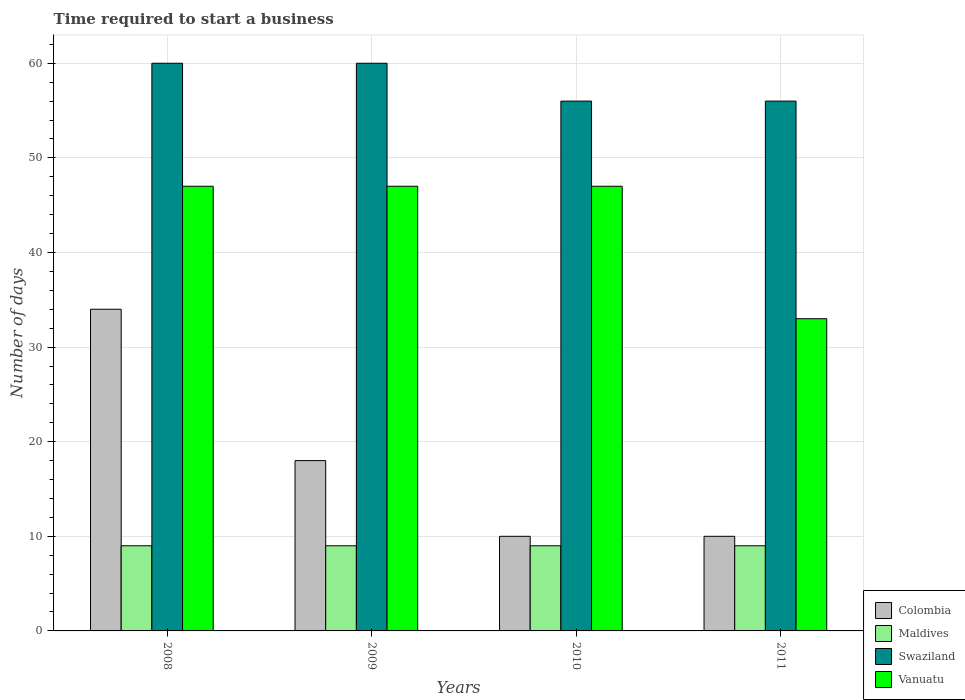How many different coloured bars are there?
Provide a short and direct response. 4. How many groups of bars are there?
Provide a succinct answer. 4. Are the number of bars per tick equal to the number of legend labels?
Provide a short and direct response. Yes. How many bars are there on the 1st tick from the left?
Provide a succinct answer. 4. How many bars are there on the 3rd tick from the right?
Provide a succinct answer. 4. What is the label of the 2nd group of bars from the left?
Your answer should be very brief. 2009. In how many cases, is the number of bars for a given year not equal to the number of legend labels?
Provide a short and direct response. 0. What is the number of days required to start a business in Maldives in 2008?
Make the answer very short. 9. Across all years, what is the maximum number of days required to start a business in Swaziland?
Ensure brevity in your answer.  60. Across all years, what is the minimum number of days required to start a business in Colombia?
Your answer should be compact. 10. In which year was the number of days required to start a business in Maldives maximum?
Your response must be concise. 2008. In which year was the number of days required to start a business in Maldives minimum?
Give a very brief answer. 2008. What is the total number of days required to start a business in Vanuatu in the graph?
Give a very brief answer. 174. What is the difference between the number of days required to start a business in Vanuatu in 2008 and that in 2010?
Keep it short and to the point. 0. What is the difference between the number of days required to start a business in Swaziland in 2011 and the number of days required to start a business in Maldives in 2010?
Provide a succinct answer. 47. In the year 2009, what is the difference between the number of days required to start a business in Maldives and number of days required to start a business in Swaziland?
Offer a very short reply. -51. Is the number of days required to start a business in Vanuatu in 2008 less than that in 2010?
Make the answer very short. No. What is the difference between the highest and the lowest number of days required to start a business in Maldives?
Provide a short and direct response. 0. What does the 2nd bar from the left in 2008 represents?
Your response must be concise. Maldives. What does the 2nd bar from the right in 2011 represents?
Your answer should be compact. Swaziland. Is it the case that in every year, the sum of the number of days required to start a business in Colombia and number of days required to start a business in Vanuatu is greater than the number of days required to start a business in Swaziland?
Your answer should be compact. No. Are all the bars in the graph horizontal?
Make the answer very short. No. Does the graph contain grids?
Make the answer very short. Yes. How many legend labels are there?
Your response must be concise. 4. What is the title of the graph?
Provide a succinct answer. Time required to start a business. What is the label or title of the X-axis?
Give a very brief answer. Years. What is the label or title of the Y-axis?
Your response must be concise. Number of days. What is the Number of days of Colombia in 2008?
Provide a short and direct response. 34. What is the Number of days of Swaziland in 2008?
Ensure brevity in your answer.  60. What is the Number of days in Maldives in 2009?
Provide a succinct answer. 9. What is the Number of days of Swaziland in 2009?
Provide a succinct answer. 60. What is the Number of days of Vanuatu in 2009?
Your response must be concise. 47. What is the Number of days of Colombia in 2010?
Ensure brevity in your answer.  10. What is the Number of days in Swaziland in 2010?
Keep it short and to the point. 56. What is the Number of days of Colombia in 2011?
Offer a very short reply. 10. What is the Number of days in Swaziland in 2011?
Provide a short and direct response. 56. Across all years, what is the maximum Number of days of Colombia?
Provide a short and direct response. 34. Across all years, what is the maximum Number of days in Maldives?
Your answer should be very brief. 9. Across all years, what is the minimum Number of days in Colombia?
Offer a very short reply. 10. Across all years, what is the minimum Number of days in Maldives?
Ensure brevity in your answer.  9. What is the total Number of days in Colombia in the graph?
Provide a succinct answer. 72. What is the total Number of days of Swaziland in the graph?
Keep it short and to the point. 232. What is the total Number of days in Vanuatu in the graph?
Ensure brevity in your answer.  174. What is the difference between the Number of days of Maldives in 2008 and that in 2009?
Provide a succinct answer. 0. What is the difference between the Number of days of Vanuatu in 2008 and that in 2009?
Ensure brevity in your answer.  0. What is the difference between the Number of days in Maldives in 2008 and that in 2010?
Offer a very short reply. 0. What is the difference between the Number of days in Vanuatu in 2008 and that in 2010?
Your answer should be compact. 0. What is the difference between the Number of days of Swaziland in 2008 and that in 2011?
Give a very brief answer. 4. What is the difference between the Number of days in Vanuatu in 2008 and that in 2011?
Your answer should be very brief. 14. What is the difference between the Number of days of Swaziland in 2009 and that in 2010?
Offer a very short reply. 4. What is the difference between the Number of days of Colombia in 2009 and that in 2011?
Your answer should be compact. 8. What is the difference between the Number of days of Swaziland in 2009 and that in 2011?
Your answer should be compact. 4. What is the difference between the Number of days of Swaziland in 2010 and that in 2011?
Give a very brief answer. 0. What is the difference between the Number of days in Vanuatu in 2010 and that in 2011?
Offer a very short reply. 14. What is the difference between the Number of days in Colombia in 2008 and the Number of days in Vanuatu in 2009?
Your answer should be very brief. -13. What is the difference between the Number of days of Maldives in 2008 and the Number of days of Swaziland in 2009?
Offer a terse response. -51. What is the difference between the Number of days in Maldives in 2008 and the Number of days in Vanuatu in 2009?
Offer a terse response. -38. What is the difference between the Number of days in Maldives in 2008 and the Number of days in Swaziland in 2010?
Provide a succinct answer. -47. What is the difference between the Number of days of Maldives in 2008 and the Number of days of Vanuatu in 2010?
Your response must be concise. -38. What is the difference between the Number of days in Colombia in 2008 and the Number of days in Maldives in 2011?
Your answer should be compact. 25. What is the difference between the Number of days in Colombia in 2008 and the Number of days in Vanuatu in 2011?
Offer a terse response. 1. What is the difference between the Number of days of Maldives in 2008 and the Number of days of Swaziland in 2011?
Provide a short and direct response. -47. What is the difference between the Number of days in Maldives in 2008 and the Number of days in Vanuatu in 2011?
Give a very brief answer. -24. What is the difference between the Number of days of Swaziland in 2008 and the Number of days of Vanuatu in 2011?
Your answer should be very brief. 27. What is the difference between the Number of days in Colombia in 2009 and the Number of days in Maldives in 2010?
Offer a very short reply. 9. What is the difference between the Number of days of Colombia in 2009 and the Number of days of Swaziland in 2010?
Provide a short and direct response. -38. What is the difference between the Number of days in Colombia in 2009 and the Number of days in Vanuatu in 2010?
Give a very brief answer. -29. What is the difference between the Number of days of Maldives in 2009 and the Number of days of Swaziland in 2010?
Ensure brevity in your answer.  -47. What is the difference between the Number of days in Maldives in 2009 and the Number of days in Vanuatu in 2010?
Provide a succinct answer. -38. What is the difference between the Number of days of Colombia in 2009 and the Number of days of Swaziland in 2011?
Keep it short and to the point. -38. What is the difference between the Number of days in Maldives in 2009 and the Number of days in Swaziland in 2011?
Keep it short and to the point. -47. What is the difference between the Number of days in Swaziland in 2009 and the Number of days in Vanuatu in 2011?
Your response must be concise. 27. What is the difference between the Number of days of Colombia in 2010 and the Number of days of Maldives in 2011?
Your answer should be compact. 1. What is the difference between the Number of days of Colombia in 2010 and the Number of days of Swaziland in 2011?
Provide a succinct answer. -46. What is the difference between the Number of days in Maldives in 2010 and the Number of days in Swaziland in 2011?
Offer a terse response. -47. What is the average Number of days in Colombia per year?
Offer a very short reply. 18. What is the average Number of days in Maldives per year?
Offer a very short reply. 9. What is the average Number of days in Swaziland per year?
Your answer should be compact. 58. What is the average Number of days of Vanuatu per year?
Provide a succinct answer. 43.5. In the year 2008, what is the difference between the Number of days of Colombia and Number of days of Maldives?
Offer a terse response. 25. In the year 2008, what is the difference between the Number of days of Maldives and Number of days of Swaziland?
Offer a terse response. -51. In the year 2008, what is the difference between the Number of days of Maldives and Number of days of Vanuatu?
Provide a succinct answer. -38. In the year 2008, what is the difference between the Number of days of Swaziland and Number of days of Vanuatu?
Ensure brevity in your answer.  13. In the year 2009, what is the difference between the Number of days in Colombia and Number of days in Swaziland?
Your response must be concise. -42. In the year 2009, what is the difference between the Number of days of Maldives and Number of days of Swaziland?
Your answer should be very brief. -51. In the year 2009, what is the difference between the Number of days in Maldives and Number of days in Vanuatu?
Provide a succinct answer. -38. In the year 2009, what is the difference between the Number of days in Swaziland and Number of days in Vanuatu?
Your response must be concise. 13. In the year 2010, what is the difference between the Number of days of Colombia and Number of days of Maldives?
Your response must be concise. 1. In the year 2010, what is the difference between the Number of days of Colombia and Number of days of Swaziland?
Offer a very short reply. -46. In the year 2010, what is the difference between the Number of days in Colombia and Number of days in Vanuatu?
Your response must be concise. -37. In the year 2010, what is the difference between the Number of days of Maldives and Number of days of Swaziland?
Your response must be concise. -47. In the year 2010, what is the difference between the Number of days in Maldives and Number of days in Vanuatu?
Your answer should be very brief. -38. In the year 2011, what is the difference between the Number of days in Colombia and Number of days in Maldives?
Offer a terse response. 1. In the year 2011, what is the difference between the Number of days in Colombia and Number of days in Swaziland?
Give a very brief answer. -46. In the year 2011, what is the difference between the Number of days in Maldives and Number of days in Swaziland?
Keep it short and to the point. -47. In the year 2011, what is the difference between the Number of days in Maldives and Number of days in Vanuatu?
Make the answer very short. -24. What is the ratio of the Number of days of Colombia in 2008 to that in 2009?
Offer a very short reply. 1.89. What is the ratio of the Number of days of Maldives in 2008 to that in 2009?
Your answer should be very brief. 1. What is the ratio of the Number of days of Colombia in 2008 to that in 2010?
Provide a short and direct response. 3.4. What is the ratio of the Number of days in Maldives in 2008 to that in 2010?
Make the answer very short. 1. What is the ratio of the Number of days in Swaziland in 2008 to that in 2010?
Your answer should be very brief. 1.07. What is the ratio of the Number of days in Vanuatu in 2008 to that in 2010?
Offer a terse response. 1. What is the ratio of the Number of days of Colombia in 2008 to that in 2011?
Your answer should be compact. 3.4. What is the ratio of the Number of days of Swaziland in 2008 to that in 2011?
Make the answer very short. 1.07. What is the ratio of the Number of days in Vanuatu in 2008 to that in 2011?
Your response must be concise. 1.42. What is the ratio of the Number of days of Swaziland in 2009 to that in 2010?
Your response must be concise. 1.07. What is the ratio of the Number of days in Vanuatu in 2009 to that in 2010?
Your answer should be very brief. 1. What is the ratio of the Number of days of Colombia in 2009 to that in 2011?
Give a very brief answer. 1.8. What is the ratio of the Number of days in Maldives in 2009 to that in 2011?
Offer a terse response. 1. What is the ratio of the Number of days in Swaziland in 2009 to that in 2011?
Your answer should be compact. 1.07. What is the ratio of the Number of days of Vanuatu in 2009 to that in 2011?
Keep it short and to the point. 1.42. What is the ratio of the Number of days of Maldives in 2010 to that in 2011?
Provide a short and direct response. 1. What is the ratio of the Number of days of Swaziland in 2010 to that in 2011?
Provide a short and direct response. 1. What is the ratio of the Number of days of Vanuatu in 2010 to that in 2011?
Your answer should be compact. 1.42. What is the difference between the highest and the second highest Number of days of Maldives?
Provide a short and direct response. 0. What is the difference between the highest and the lowest Number of days of Colombia?
Make the answer very short. 24. 